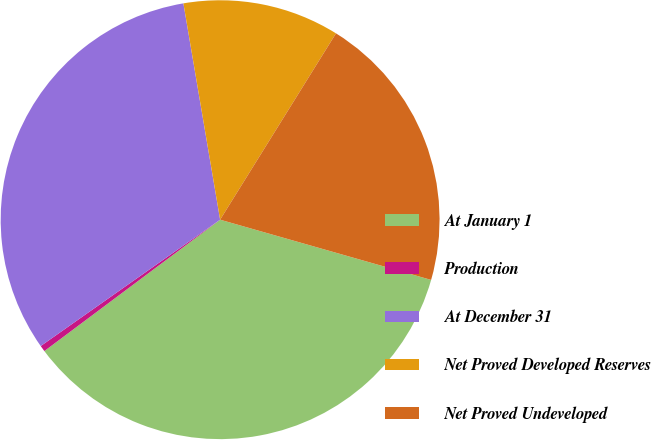Convert chart to OTSL. <chart><loc_0><loc_0><loc_500><loc_500><pie_chart><fcel>At January 1<fcel>Production<fcel>At December 31<fcel>Net Proved Developed Reserves<fcel>Net Proved Undeveloped<nl><fcel>35.36%<fcel>0.45%<fcel>32.09%<fcel>11.53%<fcel>20.57%<nl></chart> 